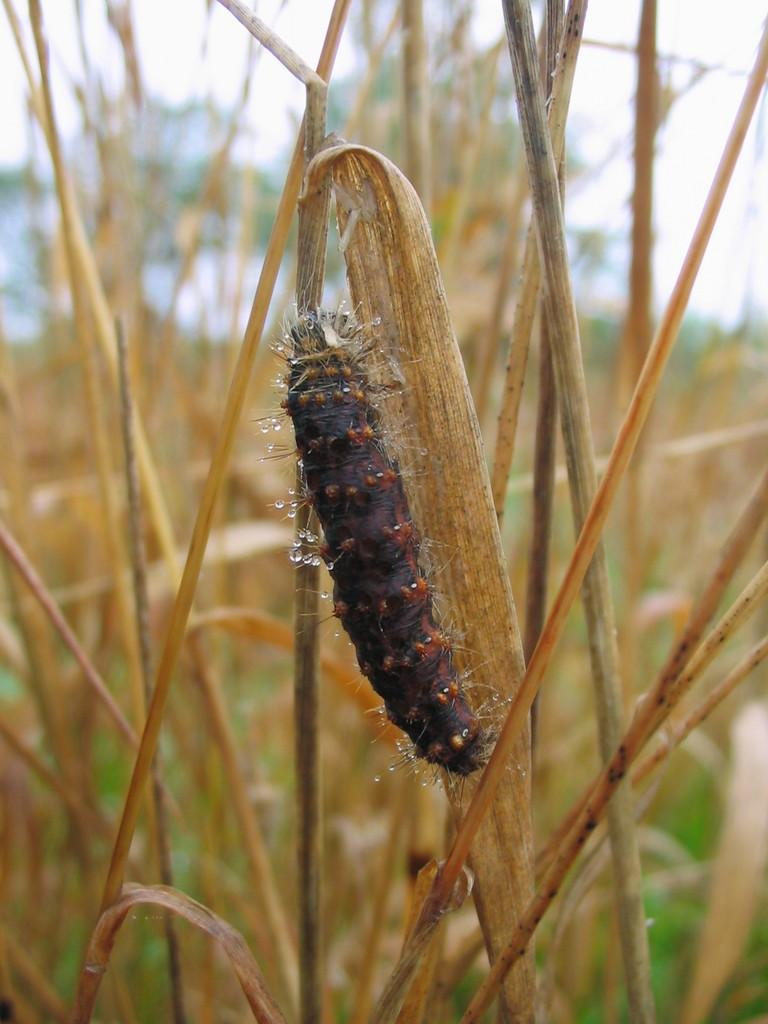What type of living organisms can be seen in the image? Plants and an insect are visible in the image. What colors are the plants in the image? The plants are green and brown in color. What colors is the insect in the image? The insect is black and orange in color. Where is the insect located in the image? The insect is on a green and brown plant. What is visible in the background of the image? The sky is visible in the background of the image. Can you hear the kittens crying in the image? There are no kittens or sounds present in the image, so it is not possible to hear any crying. 